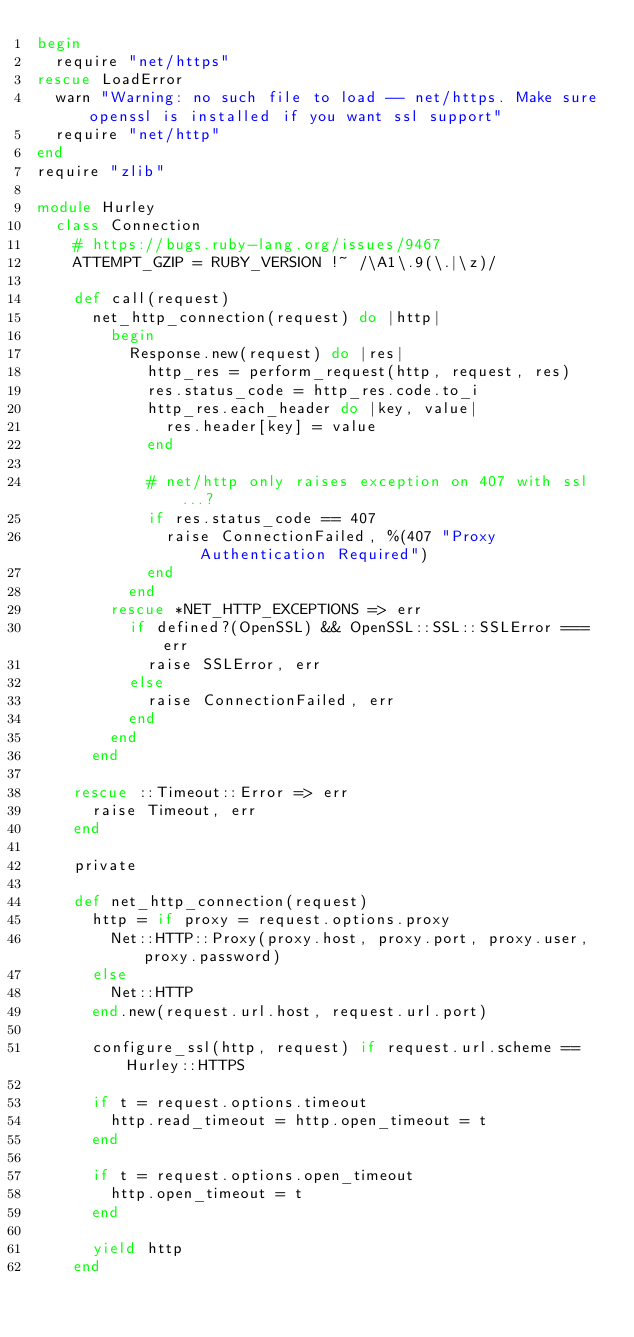<code> <loc_0><loc_0><loc_500><loc_500><_Ruby_>begin
  require "net/https"
rescue LoadError
  warn "Warning: no such file to load -- net/https. Make sure openssl is installed if you want ssl support"
  require "net/http"
end
require "zlib"

module Hurley
  class Connection
    # https://bugs.ruby-lang.org/issues/9467
    ATTEMPT_GZIP = RUBY_VERSION !~ /\A1\.9(\.|\z)/

    def call(request)
      net_http_connection(request) do |http|
        begin
          Response.new(request) do |res|
            http_res = perform_request(http, request, res)
            res.status_code = http_res.code.to_i
            http_res.each_header do |key, value|
              res.header[key] = value
            end

            # net/http only raises exception on 407 with ssl...?
            if res.status_code == 407
              raise ConnectionFailed, %(407 "Proxy Authentication Required")
            end
          end
        rescue *NET_HTTP_EXCEPTIONS => err
          if defined?(OpenSSL) && OpenSSL::SSL::SSLError === err
            raise SSLError, err
          else
            raise ConnectionFailed, err
          end
        end
      end

    rescue ::Timeout::Error => err
      raise Timeout, err
    end

    private

    def net_http_connection(request)
      http = if proxy = request.options.proxy
        Net::HTTP::Proxy(proxy.host, proxy.port, proxy.user, proxy.password)
      else
        Net::HTTP
      end.new(request.url.host, request.url.port)

      configure_ssl(http, request) if request.url.scheme == Hurley::HTTPS

      if t = request.options.timeout
        http.read_timeout = http.open_timeout = t
      end

      if t = request.options.open_timeout
        http.open_timeout = t
      end

      yield http
    end
</code> 